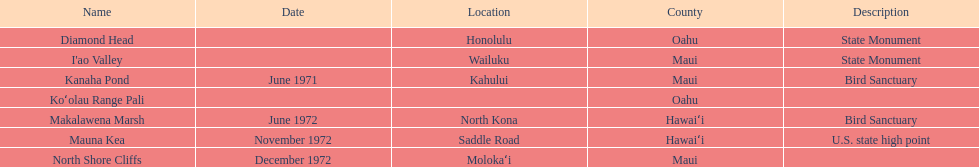Would you mind parsing the complete table? {'header': ['Name', 'Date', 'Location', 'County', 'Description'], 'rows': [['Diamond Head', '', 'Honolulu', 'Oahu', 'State Monument'], ["I'ao Valley", '', 'Wailuku', 'Maui', 'State Monument'], ['Kanaha Pond', 'June 1971', 'Kahului', 'Maui', 'Bird Sanctuary'], ['Koʻolau Range Pali', '', '', 'Oahu', ''], ['Makalawena Marsh', 'June 1972', 'North Kona', 'Hawaiʻi', 'Bird Sanctuary'], ['Mauna Kea', 'November 1972', 'Saddle Road', 'Hawaiʻi', 'U.S. state high point'], ['North Shore Cliffs', 'December 1972', 'Molokaʻi', 'Maui', '']]} What is the number of bird sanctuary landmarks? 2. 